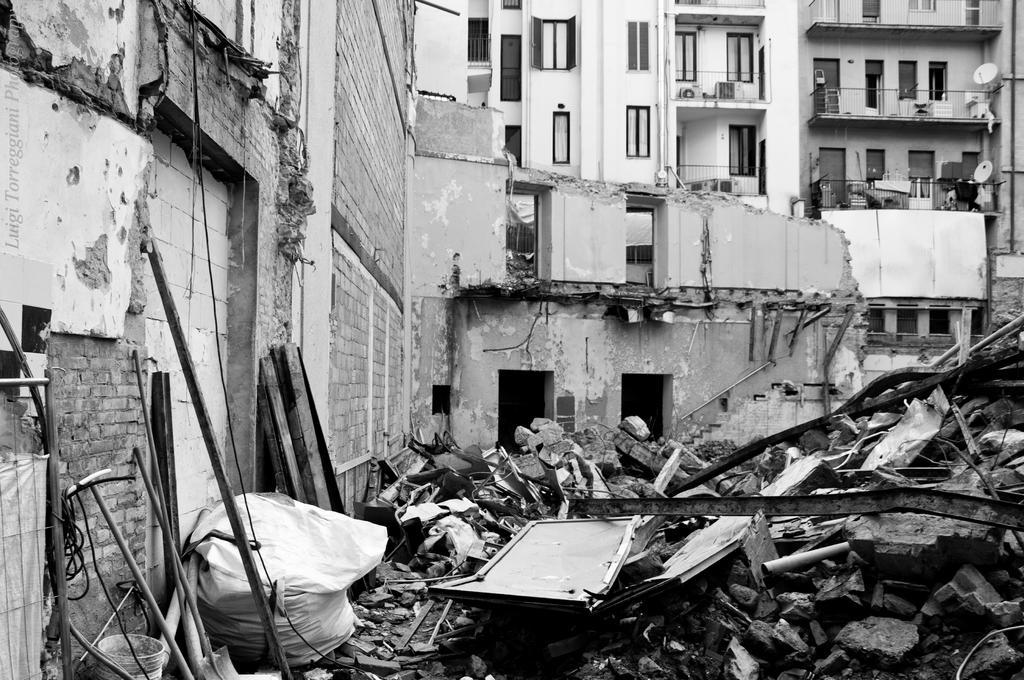In one or two sentences, can you explain what this image depicts? It is a black and white image. In this image we can see the buildings. We can also see some destructed parts of the building. On the left, we can see some sticks and also a cover and bucket. 